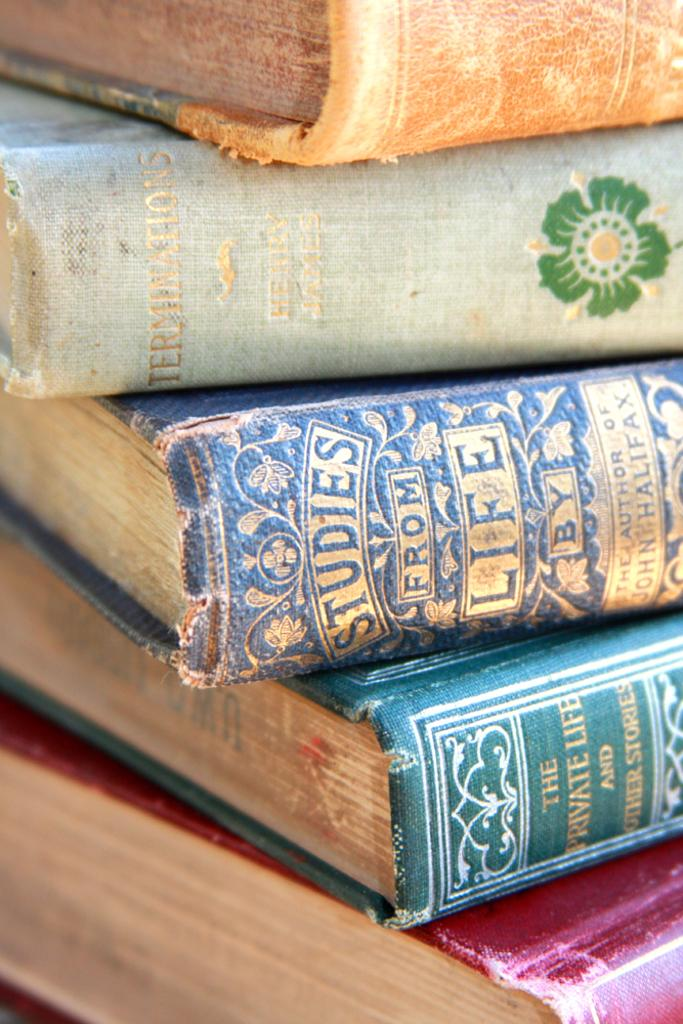<image>
Offer a succinct explanation of the picture presented. Three tattered hardcover books are titled Studies from Life. Private Life and Other Stories, and Terminations. 